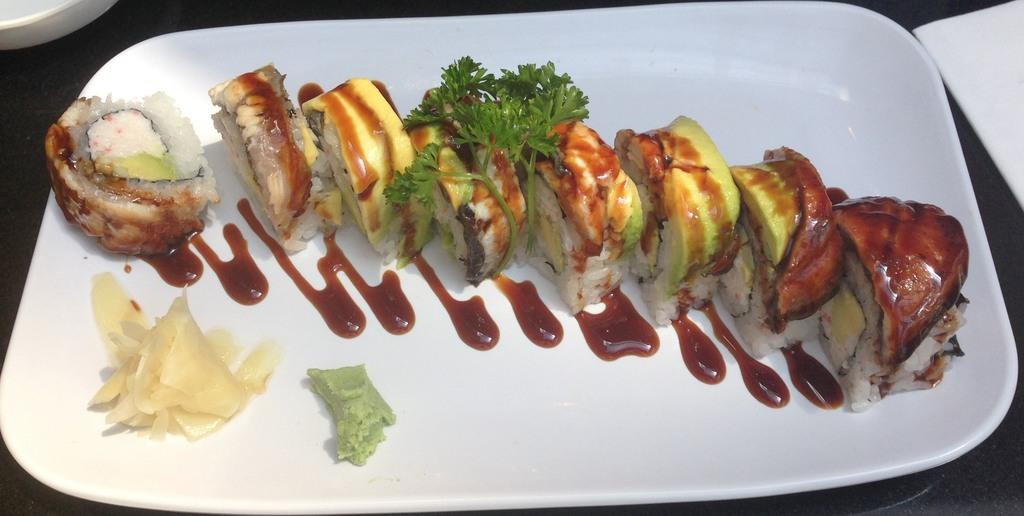What type of food can be seen in the image? There is food in the image, but the specific type cannot be determined from the provided facts. What colors are present in the food? The food has brown, red, cream, and green colors. What color is the plate that the food is on? The plate is white. What advice does the crow give to the person in the image? There is no crow present in the image, so it is not possible to answer that question. 